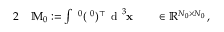Convert formula to latex. <formula><loc_0><loc_0><loc_500><loc_500>\begin{array} { r l r l } { 2 } & \mathbb { M } _ { 0 } \colon = \int { \mathbf \Lambda ^ { 0 } } ( { \mathbf \Lambda ^ { 0 } } ) ^ { \top } \, d ^ { 3 } { \mathbf x } } & \in \mathbb { R } ^ { N _ { 0 } \times N _ { 0 } } \, , } \end{array}</formula> 